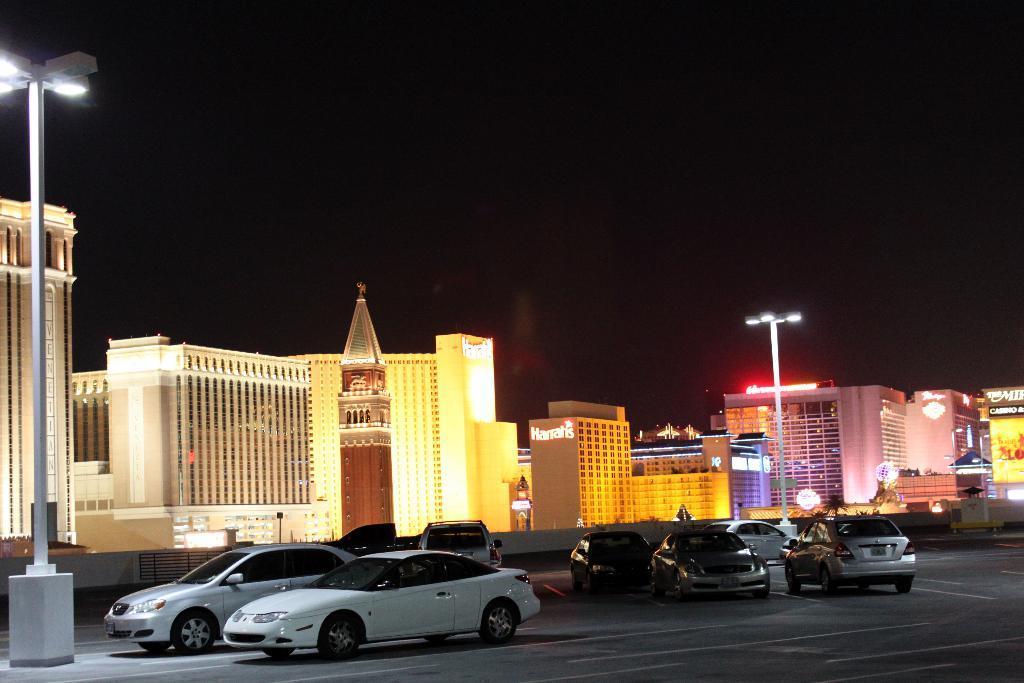Can you describe this image briefly? In this image in the center there are cars on road and there are light poles. In the background there are buildings and on the buildings there are some text written on it. 